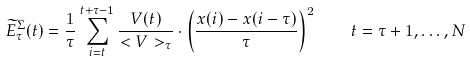<formula> <loc_0><loc_0><loc_500><loc_500>\widetilde { E } ^ { \Sigma } _ { \tau } ( t ) = \frac { 1 } { \tau } \sum _ { i = t } ^ { t + \tau - 1 } \frac { V ( t ) } { < V > _ { \tau } } \cdot \left ( \frac { x ( i ) - x ( i - \tau ) } { \tau } \right ) ^ { 2 } \quad t = \tau + 1 , \dots , N</formula> 